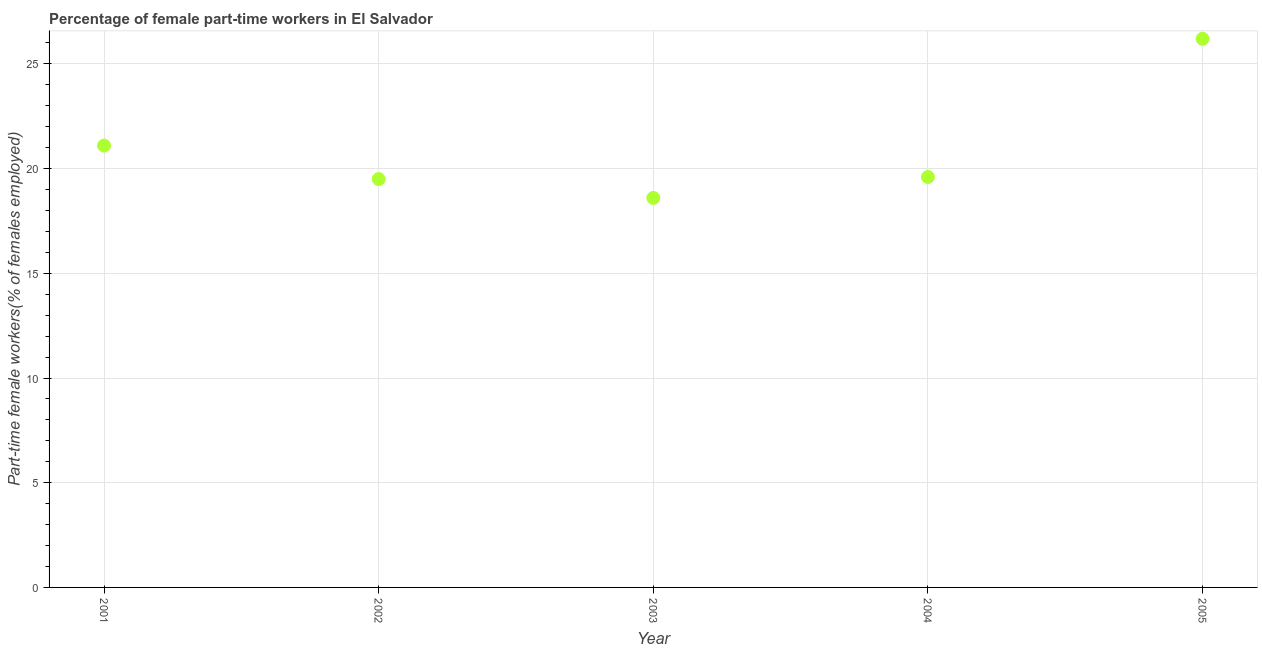What is the percentage of part-time female workers in 2003?
Offer a very short reply. 18.6. Across all years, what is the maximum percentage of part-time female workers?
Ensure brevity in your answer.  26.2. Across all years, what is the minimum percentage of part-time female workers?
Provide a short and direct response. 18.6. In which year was the percentage of part-time female workers maximum?
Provide a short and direct response. 2005. In which year was the percentage of part-time female workers minimum?
Offer a terse response. 2003. What is the sum of the percentage of part-time female workers?
Make the answer very short. 105. What is the difference between the percentage of part-time female workers in 2002 and 2005?
Your answer should be compact. -6.7. What is the average percentage of part-time female workers per year?
Provide a succinct answer. 21. What is the median percentage of part-time female workers?
Keep it short and to the point. 19.6. Do a majority of the years between 2004 and 2003 (inclusive) have percentage of part-time female workers greater than 15 %?
Your response must be concise. No. What is the ratio of the percentage of part-time female workers in 2002 to that in 2004?
Provide a succinct answer. 0.99. What is the difference between the highest and the second highest percentage of part-time female workers?
Ensure brevity in your answer.  5.1. What is the difference between the highest and the lowest percentage of part-time female workers?
Your answer should be compact. 7.6. Does the percentage of part-time female workers monotonically increase over the years?
Give a very brief answer. No. How many dotlines are there?
Your answer should be compact. 1. What is the difference between two consecutive major ticks on the Y-axis?
Offer a very short reply. 5. Are the values on the major ticks of Y-axis written in scientific E-notation?
Your answer should be very brief. No. Does the graph contain any zero values?
Make the answer very short. No. What is the title of the graph?
Offer a terse response. Percentage of female part-time workers in El Salvador. What is the label or title of the Y-axis?
Provide a succinct answer. Part-time female workers(% of females employed). What is the Part-time female workers(% of females employed) in 2001?
Make the answer very short. 21.1. What is the Part-time female workers(% of females employed) in 2002?
Ensure brevity in your answer.  19.5. What is the Part-time female workers(% of females employed) in 2003?
Provide a succinct answer. 18.6. What is the Part-time female workers(% of females employed) in 2004?
Ensure brevity in your answer.  19.6. What is the Part-time female workers(% of females employed) in 2005?
Your answer should be very brief. 26.2. What is the difference between the Part-time female workers(% of females employed) in 2001 and 2003?
Offer a very short reply. 2.5. What is the difference between the Part-time female workers(% of females employed) in 2001 and 2004?
Ensure brevity in your answer.  1.5. What is the difference between the Part-time female workers(% of females employed) in 2001 and 2005?
Give a very brief answer. -5.1. What is the difference between the Part-time female workers(% of females employed) in 2002 and 2004?
Provide a short and direct response. -0.1. What is the difference between the Part-time female workers(% of females employed) in 2002 and 2005?
Ensure brevity in your answer.  -6.7. What is the difference between the Part-time female workers(% of females employed) in 2003 and 2005?
Make the answer very short. -7.6. What is the difference between the Part-time female workers(% of females employed) in 2004 and 2005?
Offer a very short reply. -6.6. What is the ratio of the Part-time female workers(% of females employed) in 2001 to that in 2002?
Provide a succinct answer. 1.08. What is the ratio of the Part-time female workers(% of females employed) in 2001 to that in 2003?
Offer a very short reply. 1.13. What is the ratio of the Part-time female workers(% of females employed) in 2001 to that in 2004?
Ensure brevity in your answer.  1.08. What is the ratio of the Part-time female workers(% of females employed) in 2001 to that in 2005?
Provide a succinct answer. 0.81. What is the ratio of the Part-time female workers(% of females employed) in 2002 to that in 2003?
Your answer should be very brief. 1.05. What is the ratio of the Part-time female workers(% of females employed) in 2002 to that in 2005?
Your response must be concise. 0.74. What is the ratio of the Part-time female workers(% of females employed) in 2003 to that in 2004?
Make the answer very short. 0.95. What is the ratio of the Part-time female workers(% of females employed) in 2003 to that in 2005?
Provide a succinct answer. 0.71. What is the ratio of the Part-time female workers(% of females employed) in 2004 to that in 2005?
Your answer should be very brief. 0.75. 